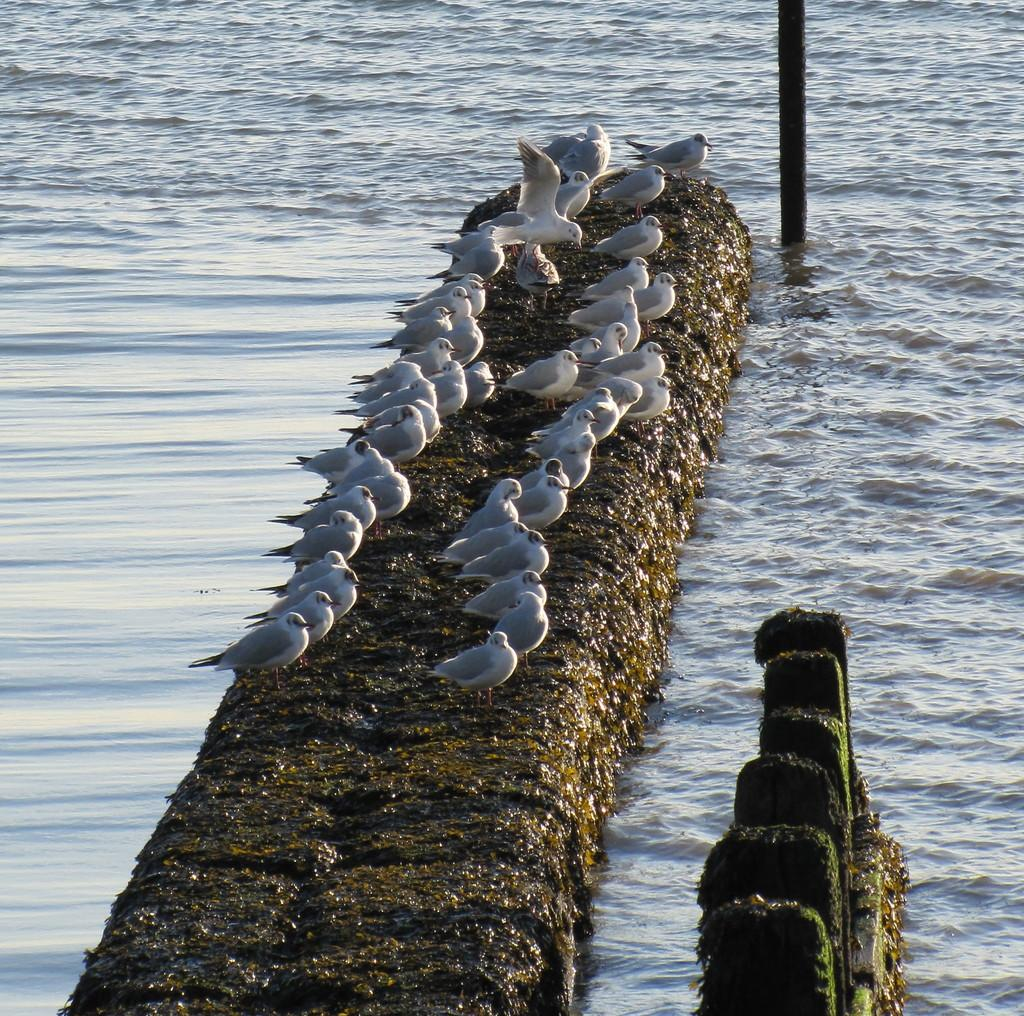What is the primary element visible in the image? There is water in the image. What type of structure can be seen in the image? There is a wall in the image. What animals are present on the wall? There are birds on the wall. What are the small poles used for in the image? The small poles are likely used for support or guidance. Can you describe the larger pole in the image? There is another pole in the image, but its purpose or function is not clear from the provided facts. What type of meal is being prepared on the observation deck in the image? There is no observation deck or meal preparation visible in the image; the image features water, a wall, birds, and poles. 